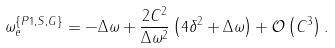<formula> <loc_0><loc_0><loc_500><loc_500>\omega _ { e } ^ { \{ P 1 , S , G \} } = - \Delta \omega + \frac { 2 C ^ { 2 } } { \Delta \omega ^ { 2 } } \left ( 4 \delta ^ { 2 } + \Delta \omega \right ) + \mathcal { O } \left ( C ^ { 3 } \right ) .</formula> 